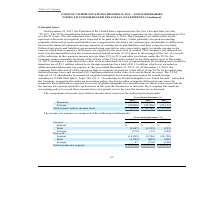From Cogent Communications Group's financial document, What are the respective domestic income before income taxes in 2017 and 2018? The document shows two values: $52,250 and $63,878 (in thousands). From the document: "r 31, 2019 2018 2017 Domestic $ 72,773 $ 63,878 $ 52,250 Foreign (20,099) (22,496) (21,132) Total income before income taxes $ 52,674 $ 41,382 $ 31,11..." Also, What are the respective domestic income before income taxes in 2018 and 2019? The document shows two values: $63,878 and $72,773 (in thousands). From the document: "ears Ended December 31, 2019 2018 2017 Domestic $ 72,773 $ 63,878 $ 52,250 Foreign (20,099) (22,496) (21,132) Total income before income taxes $ 52,67..." Also, What are the respective foreign losses before income taxes in 2017 and 2018? The document shows two values: 21,132 and 22,496 (in thousands). From the document: "stic $ 72,773 $ 63,878 $ 52,250 Foreign (20,099) (22,496) (21,132) Total income before income taxes $ 52,674 $ 41,382 $ 31,118 ,773 $ 63,878 $ 52,250 ..." Also, can you calculate: What is the average domestic income before income taxes in 2017 and 2018? To answer this question, I need to perform calculations using the financial data. The calculation is: ($52,250 + $63,878)/2 , which equals 58064 (in thousands). This is based on the information: "d December 31, 2019 2018 2017 Domestic $ 72,773 $ 63,878 $ 52,250 Foreign (20,099) (22,496) (21,132) Total income before income taxes $ 52,674 $ 41,382 $ 31 r 31, 2019 2018 2017 Domestic $ 72,773 $ 63..." The key data points involved are: 52,250, 63,878. Also, can you calculate: What is the average domestic income before income taxes in 2018 and 2019? To answer this question, I need to perform calculations using the financial data. The calculation is: ($63,878 + $72,773)/2 , which equals 68325.5 (in thousands). This is based on the information: "ears Ended December 31, 2019 2018 2017 Domestic $ 72,773 $ 63,878 $ 52,250 Foreign (20,099) (22,496) (21,132) Total income before income taxes $ 52,674 $ 41 d December 31, 2019 2018 2017 Domestic $ 72..." The key data points involved are: 63,878, 72,773. Also, can you calculate: What is the average foreign losses before income taxes in 2017 and 2018? To answer this question, I need to perform calculations using the financial data. The calculation is: (21,132 + 22,496)/2, which equals 21814 (in thousands). This is based on the information: "stic $ 72,773 $ 63,878 $ 52,250 Foreign (20,099) (22,496) (21,132) Total income before income taxes $ 52,674 $ 41,382 $ 31,118 ,773 $ 63,878 $ 52,250 Foreign (20,099) (22,496) (21,132) Total income be..." The key data points involved are: 21,132, 22,496. 